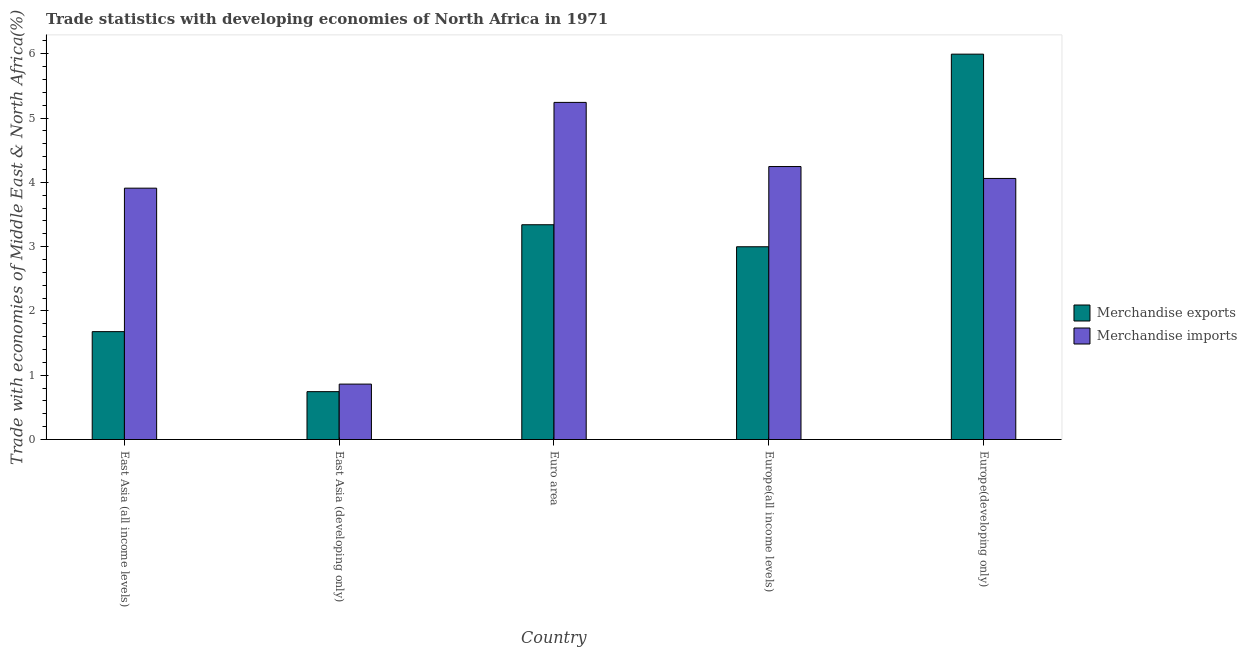Are the number of bars per tick equal to the number of legend labels?
Your answer should be compact. Yes. What is the merchandise imports in East Asia (developing only)?
Ensure brevity in your answer.  0.86. Across all countries, what is the maximum merchandise imports?
Provide a short and direct response. 5.24. Across all countries, what is the minimum merchandise exports?
Offer a very short reply. 0.74. In which country was the merchandise exports maximum?
Offer a very short reply. Europe(developing only). In which country was the merchandise imports minimum?
Provide a succinct answer. East Asia (developing only). What is the total merchandise imports in the graph?
Provide a short and direct response. 18.32. What is the difference between the merchandise exports in East Asia (all income levels) and that in Europe(all income levels)?
Your response must be concise. -1.32. What is the difference between the merchandise imports in East Asia (developing only) and the merchandise exports in Europe(developing only)?
Give a very brief answer. -5.13. What is the average merchandise exports per country?
Make the answer very short. 2.95. What is the difference between the merchandise imports and merchandise exports in Europe(developing only)?
Provide a short and direct response. -1.93. What is the ratio of the merchandise exports in Euro area to that in Europe(all income levels)?
Offer a very short reply. 1.11. What is the difference between the highest and the second highest merchandise exports?
Make the answer very short. 2.65. What is the difference between the highest and the lowest merchandise imports?
Offer a terse response. 4.38. How many bars are there?
Your response must be concise. 10. Are all the bars in the graph horizontal?
Keep it short and to the point. No. How many countries are there in the graph?
Your answer should be compact. 5. What is the difference between two consecutive major ticks on the Y-axis?
Your response must be concise. 1. Are the values on the major ticks of Y-axis written in scientific E-notation?
Offer a very short reply. No. Does the graph contain grids?
Your response must be concise. No. Where does the legend appear in the graph?
Ensure brevity in your answer.  Center right. How many legend labels are there?
Your response must be concise. 2. What is the title of the graph?
Give a very brief answer. Trade statistics with developing economies of North Africa in 1971. What is the label or title of the X-axis?
Provide a short and direct response. Country. What is the label or title of the Y-axis?
Ensure brevity in your answer.  Trade with economies of Middle East & North Africa(%). What is the Trade with economies of Middle East & North Africa(%) in Merchandise exports in East Asia (all income levels)?
Keep it short and to the point. 1.68. What is the Trade with economies of Middle East & North Africa(%) of Merchandise imports in East Asia (all income levels)?
Offer a very short reply. 3.91. What is the Trade with economies of Middle East & North Africa(%) of Merchandise exports in East Asia (developing only)?
Offer a very short reply. 0.74. What is the Trade with economies of Middle East & North Africa(%) in Merchandise imports in East Asia (developing only)?
Your answer should be very brief. 0.86. What is the Trade with economies of Middle East & North Africa(%) in Merchandise exports in Euro area?
Ensure brevity in your answer.  3.34. What is the Trade with economies of Middle East & North Africa(%) in Merchandise imports in Euro area?
Your answer should be very brief. 5.24. What is the Trade with economies of Middle East & North Africa(%) of Merchandise exports in Europe(all income levels)?
Offer a very short reply. 3. What is the Trade with economies of Middle East & North Africa(%) of Merchandise imports in Europe(all income levels)?
Ensure brevity in your answer.  4.25. What is the Trade with economies of Middle East & North Africa(%) of Merchandise exports in Europe(developing only)?
Your answer should be compact. 5.99. What is the Trade with economies of Middle East & North Africa(%) in Merchandise imports in Europe(developing only)?
Your answer should be compact. 4.06. Across all countries, what is the maximum Trade with economies of Middle East & North Africa(%) of Merchandise exports?
Your answer should be compact. 5.99. Across all countries, what is the maximum Trade with economies of Middle East & North Africa(%) in Merchandise imports?
Keep it short and to the point. 5.24. Across all countries, what is the minimum Trade with economies of Middle East & North Africa(%) in Merchandise exports?
Your answer should be very brief. 0.74. Across all countries, what is the minimum Trade with economies of Middle East & North Africa(%) in Merchandise imports?
Make the answer very short. 0.86. What is the total Trade with economies of Middle East & North Africa(%) in Merchandise exports in the graph?
Your answer should be very brief. 14.75. What is the total Trade with economies of Middle East & North Africa(%) in Merchandise imports in the graph?
Your response must be concise. 18.32. What is the difference between the Trade with economies of Middle East & North Africa(%) in Merchandise exports in East Asia (all income levels) and that in East Asia (developing only)?
Your answer should be compact. 0.93. What is the difference between the Trade with economies of Middle East & North Africa(%) in Merchandise imports in East Asia (all income levels) and that in East Asia (developing only)?
Make the answer very short. 3.05. What is the difference between the Trade with economies of Middle East & North Africa(%) in Merchandise exports in East Asia (all income levels) and that in Euro area?
Make the answer very short. -1.66. What is the difference between the Trade with economies of Middle East & North Africa(%) in Merchandise imports in East Asia (all income levels) and that in Euro area?
Ensure brevity in your answer.  -1.33. What is the difference between the Trade with economies of Middle East & North Africa(%) of Merchandise exports in East Asia (all income levels) and that in Europe(all income levels)?
Offer a terse response. -1.32. What is the difference between the Trade with economies of Middle East & North Africa(%) of Merchandise imports in East Asia (all income levels) and that in Europe(all income levels)?
Make the answer very short. -0.34. What is the difference between the Trade with economies of Middle East & North Africa(%) of Merchandise exports in East Asia (all income levels) and that in Europe(developing only)?
Provide a succinct answer. -4.32. What is the difference between the Trade with economies of Middle East & North Africa(%) in Merchandise imports in East Asia (all income levels) and that in Europe(developing only)?
Offer a very short reply. -0.15. What is the difference between the Trade with economies of Middle East & North Africa(%) in Merchandise exports in East Asia (developing only) and that in Euro area?
Your answer should be very brief. -2.6. What is the difference between the Trade with economies of Middle East & North Africa(%) in Merchandise imports in East Asia (developing only) and that in Euro area?
Offer a terse response. -4.38. What is the difference between the Trade with economies of Middle East & North Africa(%) of Merchandise exports in East Asia (developing only) and that in Europe(all income levels)?
Your response must be concise. -2.25. What is the difference between the Trade with economies of Middle East & North Africa(%) in Merchandise imports in East Asia (developing only) and that in Europe(all income levels)?
Make the answer very short. -3.38. What is the difference between the Trade with economies of Middle East & North Africa(%) in Merchandise exports in East Asia (developing only) and that in Europe(developing only)?
Your response must be concise. -5.25. What is the difference between the Trade with economies of Middle East & North Africa(%) of Merchandise imports in East Asia (developing only) and that in Europe(developing only)?
Your response must be concise. -3.2. What is the difference between the Trade with economies of Middle East & North Africa(%) of Merchandise exports in Euro area and that in Europe(all income levels)?
Provide a short and direct response. 0.34. What is the difference between the Trade with economies of Middle East & North Africa(%) in Merchandise imports in Euro area and that in Europe(all income levels)?
Your answer should be compact. 1. What is the difference between the Trade with economies of Middle East & North Africa(%) in Merchandise exports in Euro area and that in Europe(developing only)?
Make the answer very short. -2.65. What is the difference between the Trade with economies of Middle East & North Africa(%) of Merchandise imports in Euro area and that in Europe(developing only)?
Keep it short and to the point. 1.18. What is the difference between the Trade with economies of Middle East & North Africa(%) in Merchandise exports in Europe(all income levels) and that in Europe(developing only)?
Your response must be concise. -3. What is the difference between the Trade with economies of Middle East & North Africa(%) of Merchandise imports in Europe(all income levels) and that in Europe(developing only)?
Your response must be concise. 0.19. What is the difference between the Trade with economies of Middle East & North Africa(%) in Merchandise exports in East Asia (all income levels) and the Trade with economies of Middle East & North Africa(%) in Merchandise imports in East Asia (developing only)?
Your answer should be compact. 0.82. What is the difference between the Trade with economies of Middle East & North Africa(%) of Merchandise exports in East Asia (all income levels) and the Trade with economies of Middle East & North Africa(%) of Merchandise imports in Euro area?
Ensure brevity in your answer.  -3.56. What is the difference between the Trade with economies of Middle East & North Africa(%) in Merchandise exports in East Asia (all income levels) and the Trade with economies of Middle East & North Africa(%) in Merchandise imports in Europe(all income levels)?
Provide a succinct answer. -2.57. What is the difference between the Trade with economies of Middle East & North Africa(%) in Merchandise exports in East Asia (all income levels) and the Trade with economies of Middle East & North Africa(%) in Merchandise imports in Europe(developing only)?
Give a very brief answer. -2.38. What is the difference between the Trade with economies of Middle East & North Africa(%) of Merchandise exports in East Asia (developing only) and the Trade with economies of Middle East & North Africa(%) of Merchandise imports in Euro area?
Offer a very short reply. -4.5. What is the difference between the Trade with economies of Middle East & North Africa(%) of Merchandise exports in East Asia (developing only) and the Trade with economies of Middle East & North Africa(%) of Merchandise imports in Europe(all income levels)?
Make the answer very short. -3.5. What is the difference between the Trade with economies of Middle East & North Africa(%) of Merchandise exports in East Asia (developing only) and the Trade with economies of Middle East & North Africa(%) of Merchandise imports in Europe(developing only)?
Offer a very short reply. -3.32. What is the difference between the Trade with economies of Middle East & North Africa(%) in Merchandise exports in Euro area and the Trade with economies of Middle East & North Africa(%) in Merchandise imports in Europe(all income levels)?
Offer a terse response. -0.91. What is the difference between the Trade with economies of Middle East & North Africa(%) of Merchandise exports in Euro area and the Trade with economies of Middle East & North Africa(%) of Merchandise imports in Europe(developing only)?
Give a very brief answer. -0.72. What is the difference between the Trade with economies of Middle East & North Africa(%) in Merchandise exports in Europe(all income levels) and the Trade with economies of Middle East & North Africa(%) in Merchandise imports in Europe(developing only)?
Offer a very short reply. -1.06. What is the average Trade with economies of Middle East & North Africa(%) in Merchandise exports per country?
Make the answer very short. 2.95. What is the average Trade with economies of Middle East & North Africa(%) of Merchandise imports per country?
Keep it short and to the point. 3.66. What is the difference between the Trade with economies of Middle East & North Africa(%) of Merchandise exports and Trade with economies of Middle East & North Africa(%) of Merchandise imports in East Asia (all income levels)?
Ensure brevity in your answer.  -2.23. What is the difference between the Trade with economies of Middle East & North Africa(%) of Merchandise exports and Trade with economies of Middle East & North Africa(%) of Merchandise imports in East Asia (developing only)?
Give a very brief answer. -0.12. What is the difference between the Trade with economies of Middle East & North Africa(%) in Merchandise exports and Trade with economies of Middle East & North Africa(%) in Merchandise imports in Euro area?
Offer a very short reply. -1.9. What is the difference between the Trade with economies of Middle East & North Africa(%) of Merchandise exports and Trade with economies of Middle East & North Africa(%) of Merchandise imports in Europe(all income levels)?
Your answer should be very brief. -1.25. What is the difference between the Trade with economies of Middle East & North Africa(%) of Merchandise exports and Trade with economies of Middle East & North Africa(%) of Merchandise imports in Europe(developing only)?
Give a very brief answer. 1.93. What is the ratio of the Trade with economies of Middle East & North Africa(%) in Merchandise exports in East Asia (all income levels) to that in East Asia (developing only)?
Ensure brevity in your answer.  2.25. What is the ratio of the Trade with economies of Middle East & North Africa(%) of Merchandise imports in East Asia (all income levels) to that in East Asia (developing only)?
Your answer should be compact. 4.54. What is the ratio of the Trade with economies of Middle East & North Africa(%) in Merchandise exports in East Asia (all income levels) to that in Euro area?
Provide a short and direct response. 0.5. What is the ratio of the Trade with economies of Middle East & North Africa(%) of Merchandise imports in East Asia (all income levels) to that in Euro area?
Provide a short and direct response. 0.75. What is the ratio of the Trade with economies of Middle East & North Africa(%) of Merchandise exports in East Asia (all income levels) to that in Europe(all income levels)?
Ensure brevity in your answer.  0.56. What is the ratio of the Trade with economies of Middle East & North Africa(%) in Merchandise imports in East Asia (all income levels) to that in Europe(all income levels)?
Give a very brief answer. 0.92. What is the ratio of the Trade with economies of Middle East & North Africa(%) in Merchandise exports in East Asia (all income levels) to that in Europe(developing only)?
Provide a succinct answer. 0.28. What is the ratio of the Trade with economies of Middle East & North Africa(%) of Merchandise imports in East Asia (all income levels) to that in Europe(developing only)?
Your answer should be compact. 0.96. What is the ratio of the Trade with economies of Middle East & North Africa(%) of Merchandise exports in East Asia (developing only) to that in Euro area?
Your answer should be very brief. 0.22. What is the ratio of the Trade with economies of Middle East & North Africa(%) in Merchandise imports in East Asia (developing only) to that in Euro area?
Keep it short and to the point. 0.16. What is the ratio of the Trade with economies of Middle East & North Africa(%) in Merchandise exports in East Asia (developing only) to that in Europe(all income levels)?
Offer a terse response. 0.25. What is the ratio of the Trade with economies of Middle East & North Africa(%) of Merchandise imports in East Asia (developing only) to that in Europe(all income levels)?
Provide a short and direct response. 0.2. What is the ratio of the Trade with economies of Middle East & North Africa(%) in Merchandise exports in East Asia (developing only) to that in Europe(developing only)?
Provide a succinct answer. 0.12. What is the ratio of the Trade with economies of Middle East & North Africa(%) of Merchandise imports in East Asia (developing only) to that in Europe(developing only)?
Ensure brevity in your answer.  0.21. What is the ratio of the Trade with economies of Middle East & North Africa(%) in Merchandise exports in Euro area to that in Europe(all income levels)?
Offer a very short reply. 1.11. What is the ratio of the Trade with economies of Middle East & North Africa(%) of Merchandise imports in Euro area to that in Europe(all income levels)?
Your answer should be very brief. 1.24. What is the ratio of the Trade with economies of Middle East & North Africa(%) in Merchandise exports in Euro area to that in Europe(developing only)?
Provide a succinct answer. 0.56. What is the ratio of the Trade with economies of Middle East & North Africa(%) of Merchandise imports in Euro area to that in Europe(developing only)?
Give a very brief answer. 1.29. What is the ratio of the Trade with economies of Middle East & North Africa(%) of Merchandise exports in Europe(all income levels) to that in Europe(developing only)?
Provide a short and direct response. 0.5. What is the ratio of the Trade with economies of Middle East & North Africa(%) in Merchandise imports in Europe(all income levels) to that in Europe(developing only)?
Your answer should be very brief. 1.05. What is the difference between the highest and the second highest Trade with economies of Middle East & North Africa(%) in Merchandise exports?
Keep it short and to the point. 2.65. What is the difference between the highest and the lowest Trade with economies of Middle East & North Africa(%) of Merchandise exports?
Keep it short and to the point. 5.25. What is the difference between the highest and the lowest Trade with economies of Middle East & North Africa(%) in Merchandise imports?
Offer a very short reply. 4.38. 